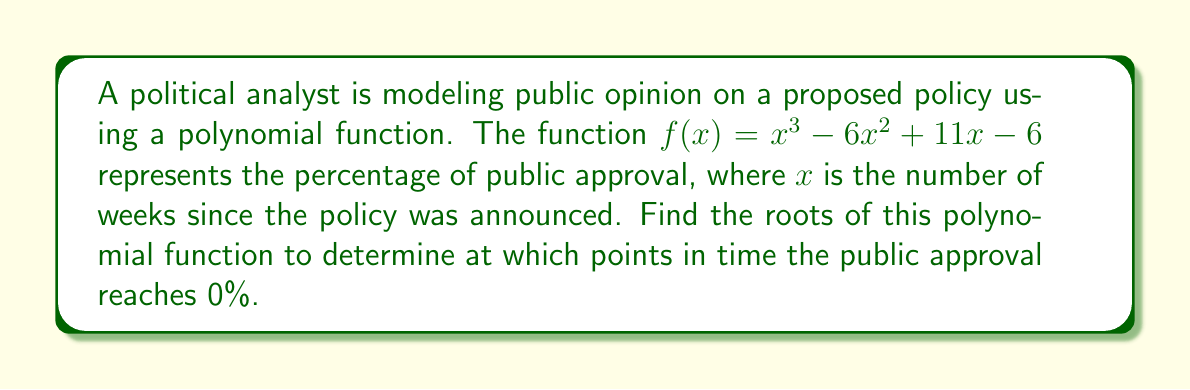Can you answer this question? To find the roots of the polynomial function, we need to factor it and solve for $f(x) = 0$.

1) First, let's check if there are any rational roots using the rational root theorem. The possible rational roots are the factors of the constant term: $\pm 1, \pm 2, \pm 3, \pm 6$.

2) Testing these values, we find that $f(1) = 0$. So, $(x-1)$ is a factor.

3) We can use polynomial long division to divide $f(x)$ by $(x-1)$:

   $x^3 - 6x^2 + 11x - 6 = (x-1)(x^2 - 5x + 6)$

4) Now we need to factor the quadratic term $x^2 - 5x + 6$:

   $x^2 - 5x + 6 = (x-2)(x-3)$

5) Therefore, the complete factorization is:

   $f(x) = (x-1)(x-2)(x-3)$

6) The roots of the polynomial are the values that make each factor equal to zero:

   $x-1 = 0$, $x = 1$
   $x-2 = 0$, $x = 2$
   $x-3 = 0$, $x = 3$

These roots represent the number of weeks at which public approval reaches 0%.
Answer: The roots of the polynomial are $x = 1$, $x = 2$, and $x = 3$. This means the public approval reaches 0% at 1 week, 2 weeks, and 3 weeks after the policy announcement. 